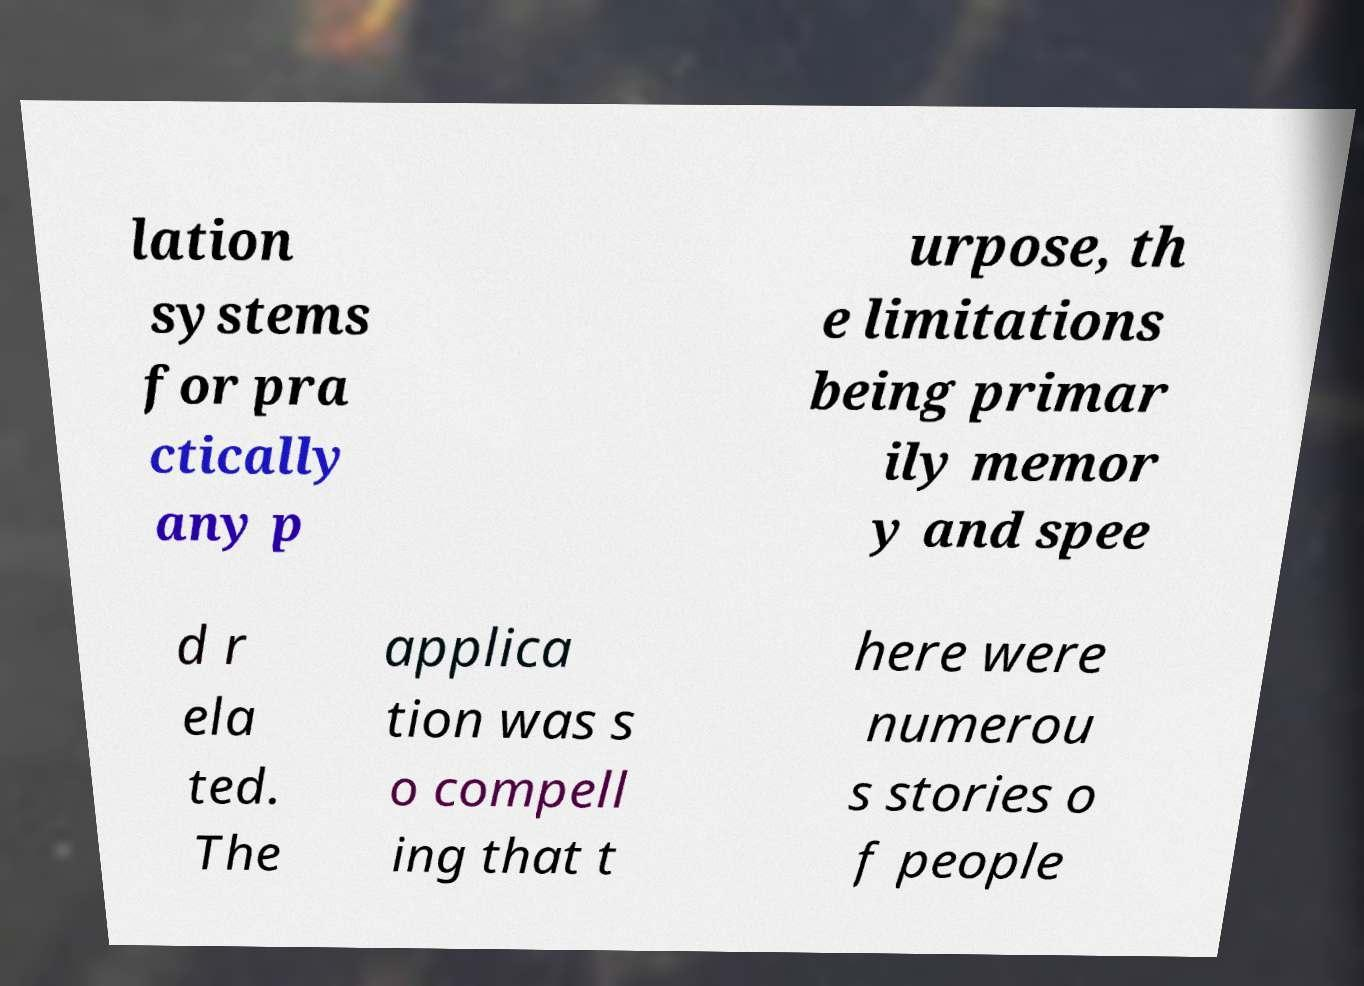I need the written content from this picture converted into text. Can you do that? lation systems for pra ctically any p urpose, th e limitations being primar ily memor y and spee d r ela ted. The applica tion was s o compell ing that t here were numerou s stories o f people 